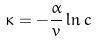Convert formula to latex. <formula><loc_0><loc_0><loc_500><loc_500>\kappa = - \frac { \alpha } { v } \ln c</formula> 